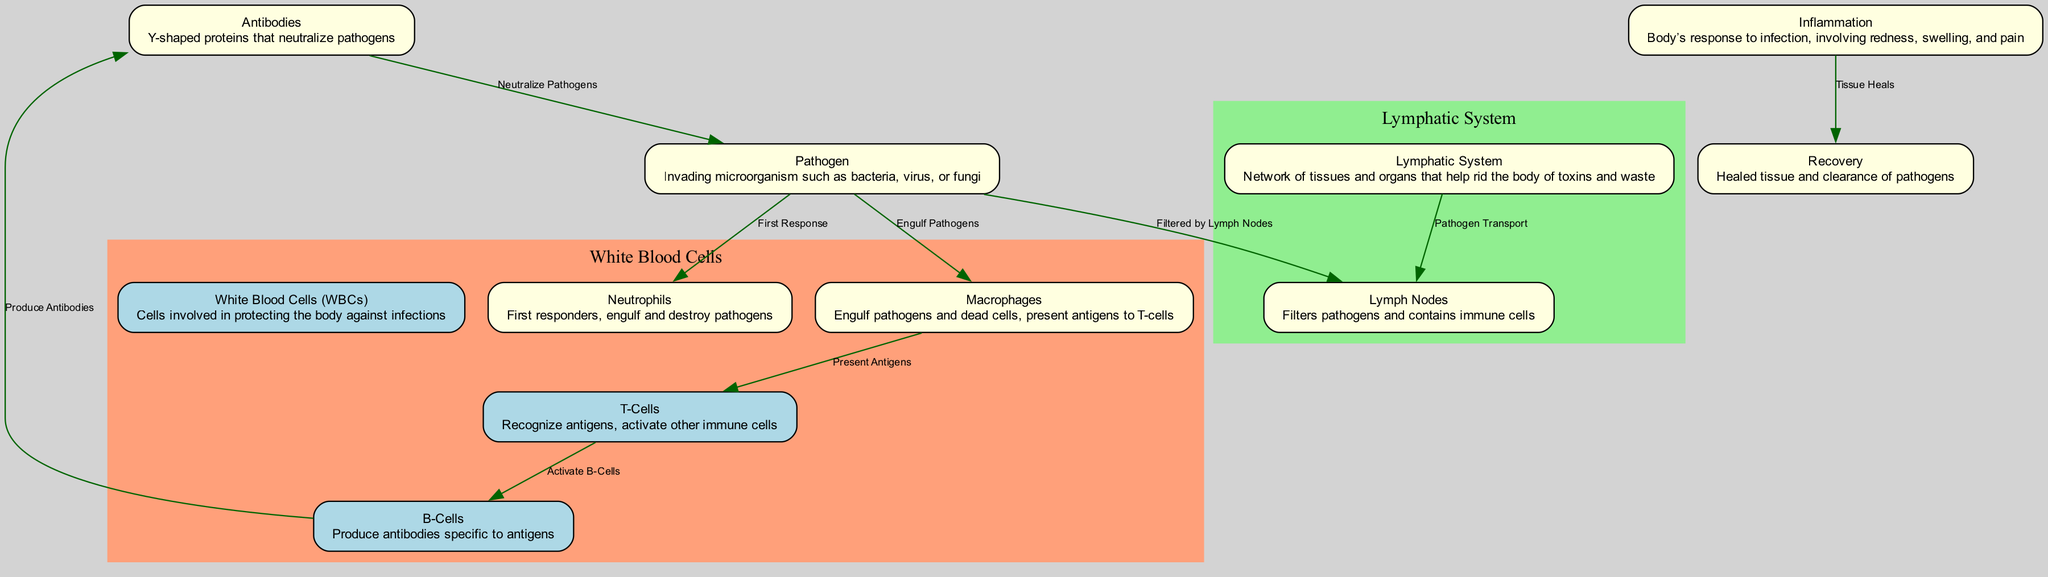What does the term "pathogen" refer to? The term "pathogen" refers to invading microorganisms such as bacteria, viruses, or fungi, as defined in the diagram.
Answer: Invading microorganism Which type of cells are the first responders to pathogens? According to the diagram, neutrophils are identified as the first responders that act against pathogens.
Answer: Neutrophils How do macrophages interact with T-cells? The diagram shows that macrophages present antigens to T-cells after engulfing pathogens and dead cells, thereby activating the T-cell response.
Answer: Present Antigens What do B-cells produce? Based on the diagram, B-cells are responsible for producing antibodies that are specific to the antigens presented to them.
Answer: Antibodies What is the relationship between inflammation and recovery in the immune response? The diagram indicates that the process of inflammation leads to recovery as the body heals and clears pathogens after an infection.
Answer: Tissue Heals How many nodes are present in the diagram? By counting the nodes listed in the diagram, there are a total of 11 nodes, including all components of the immune response.
Answer: 11 What role do lymph nodes play in the immune system? The diagram specifies that lymph nodes filter pathogens and contain immune cells that respond to infections.
Answer: Filter pathogens Which cells activate B-cells? According to the diagram, T-cells are responsible for activating B-cells during the immune response process.
Answer: T-cells 